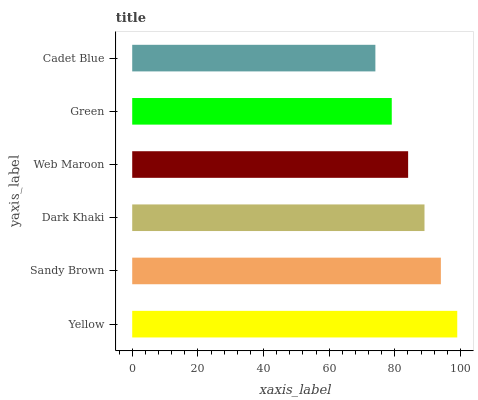Is Cadet Blue the minimum?
Answer yes or no. Yes. Is Yellow the maximum?
Answer yes or no. Yes. Is Sandy Brown the minimum?
Answer yes or no. No. Is Sandy Brown the maximum?
Answer yes or no. No. Is Yellow greater than Sandy Brown?
Answer yes or no. Yes. Is Sandy Brown less than Yellow?
Answer yes or no. Yes. Is Sandy Brown greater than Yellow?
Answer yes or no. No. Is Yellow less than Sandy Brown?
Answer yes or no. No. Is Dark Khaki the high median?
Answer yes or no. Yes. Is Web Maroon the low median?
Answer yes or no. Yes. Is Yellow the high median?
Answer yes or no. No. Is Sandy Brown the low median?
Answer yes or no. No. 